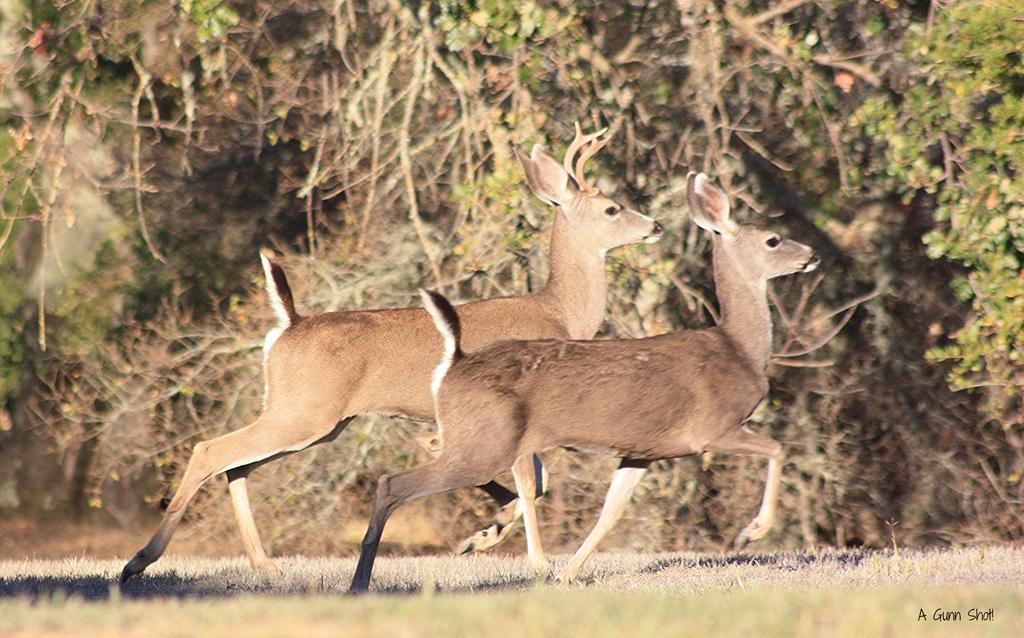Can you describe this image briefly? In this picture, we see two deer are running. At the bottom, we see the grass. There are trees in the background. This might be an edited image. This picture might be clicked in the forest or in a zoo. 